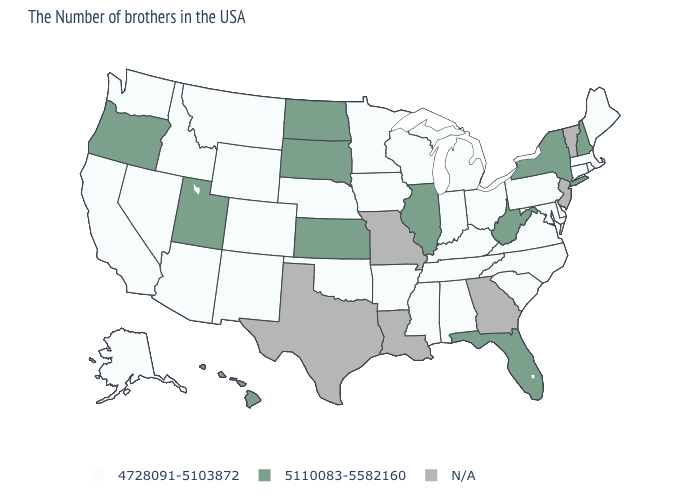Does the map have missing data?
Concise answer only. Yes. Which states have the lowest value in the West?
Concise answer only. Wyoming, Colorado, New Mexico, Montana, Arizona, Idaho, Nevada, California, Washington, Alaska. What is the value of Oregon?
Concise answer only. 5110083-5582160. Name the states that have a value in the range 5110083-5582160?
Write a very short answer. New Hampshire, New York, West Virginia, Florida, Illinois, Kansas, South Dakota, North Dakota, Utah, Oregon, Hawaii. Name the states that have a value in the range 5110083-5582160?
Short answer required. New Hampshire, New York, West Virginia, Florida, Illinois, Kansas, South Dakota, North Dakota, Utah, Oregon, Hawaii. Name the states that have a value in the range N/A?
Be succinct. Vermont, New Jersey, Georgia, Louisiana, Missouri, Texas. What is the lowest value in the USA?
Concise answer only. 4728091-5103872. Name the states that have a value in the range 5110083-5582160?
Quick response, please. New Hampshire, New York, West Virginia, Florida, Illinois, Kansas, South Dakota, North Dakota, Utah, Oregon, Hawaii. Name the states that have a value in the range N/A?
Concise answer only. Vermont, New Jersey, Georgia, Louisiana, Missouri, Texas. Name the states that have a value in the range 5110083-5582160?
Concise answer only. New Hampshire, New York, West Virginia, Florida, Illinois, Kansas, South Dakota, North Dakota, Utah, Oregon, Hawaii. Does the first symbol in the legend represent the smallest category?
Keep it brief. Yes. Which states have the highest value in the USA?
Quick response, please. New Hampshire, New York, West Virginia, Florida, Illinois, Kansas, South Dakota, North Dakota, Utah, Oregon, Hawaii. Is the legend a continuous bar?
Be succinct. No. Name the states that have a value in the range N/A?
Keep it brief. Vermont, New Jersey, Georgia, Louisiana, Missouri, Texas. Does Kansas have the highest value in the USA?
Answer briefly. Yes. 